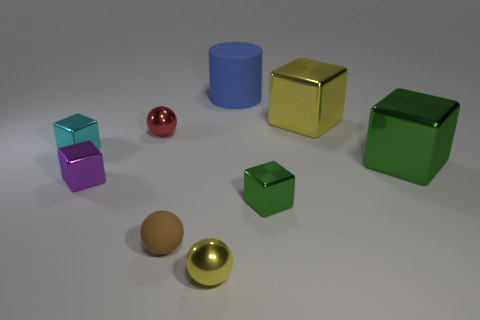Subtract all yellow cubes. How many cubes are left? 4 Subtract all small cyan shiny cubes. How many cubes are left? 4 Subtract all brown blocks. Subtract all brown cylinders. How many blocks are left? 5 Add 1 gray metal cubes. How many objects exist? 10 Subtract all spheres. How many objects are left? 6 Add 9 yellow metal balls. How many yellow metal balls exist? 10 Subtract 0 cyan balls. How many objects are left? 9 Subtract all green spheres. Subtract all rubber objects. How many objects are left? 7 Add 7 tiny purple metal objects. How many tiny purple metal objects are left? 8 